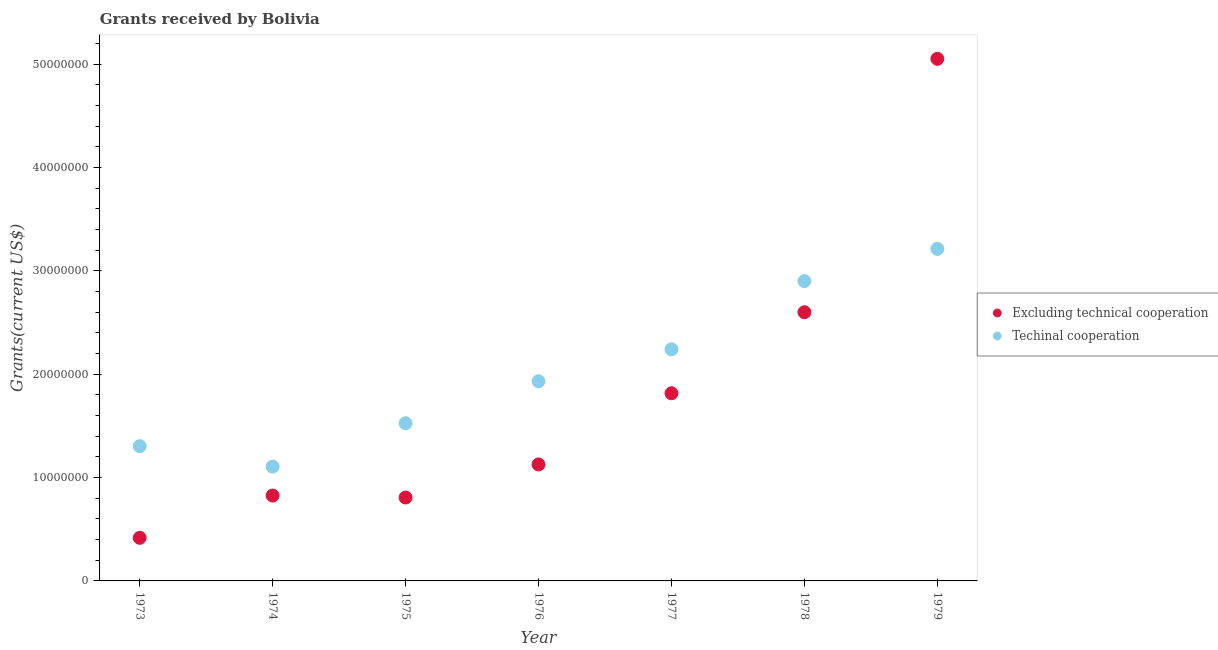How many different coloured dotlines are there?
Offer a very short reply. 2. What is the amount of grants received(including technical cooperation) in 1977?
Your answer should be very brief. 2.24e+07. Across all years, what is the maximum amount of grants received(including technical cooperation)?
Provide a succinct answer. 3.21e+07. Across all years, what is the minimum amount of grants received(excluding technical cooperation)?
Your answer should be compact. 4.17e+06. In which year was the amount of grants received(including technical cooperation) maximum?
Provide a succinct answer. 1979. In which year was the amount of grants received(including technical cooperation) minimum?
Provide a succinct answer. 1974. What is the total amount of grants received(including technical cooperation) in the graph?
Your answer should be very brief. 1.42e+08. What is the difference between the amount of grants received(including technical cooperation) in 1973 and that in 1979?
Your answer should be very brief. -1.91e+07. What is the difference between the amount of grants received(including technical cooperation) in 1974 and the amount of grants received(excluding technical cooperation) in 1977?
Provide a short and direct response. -7.10e+06. What is the average amount of grants received(including technical cooperation) per year?
Provide a succinct answer. 2.03e+07. In the year 1973, what is the difference between the amount of grants received(excluding technical cooperation) and amount of grants received(including technical cooperation)?
Offer a terse response. -8.87e+06. What is the ratio of the amount of grants received(including technical cooperation) in 1973 to that in 1977?
Your answer should be compact. 0.58. Is the amount of grants received(excluding technical cooperation) in 1975 less than that in 1976?
Keep it short and to the point. Yes. Is the difference between the amount of grants received(including technical cooperation) in 1975 and 1979 greater than the difference between the amount of grants received(excluding technical cooperation) in 1975 and 1979?
Your answer should be very brief. Yes. What is the difference between the highest and the second highest amount of grants received(excluding technical cooperation)?
Provide a short and direct response. 2.45e+07. What is the difference between the highest and the lowest amount of grants received(excluding technical cooperation)?
Your response must be concise. 4.64e+07. In how many years, is the amount of grants received(excluding technical cooperation) greater than the average amount of grants received(excluding technical cooperation) taken over all years?
Ensure brevity in your answer.  3. Is the sum of the amount of grants received(excluding technical cooperation) in 1974 and 1977 greater than the maximum amount of grants received(including technical cooperation) across all years?
Your answer should be compact. No. How many dotlines are there?
Offer a very short reply. 2. How many years are there in the graph?
Offer a very short reply. 7. What is the difference between two consecutive major ticks on the Y-axis?
Make the answer very short. 1.00e+07. Are the values on the major ticks of Y-axis written in scientific E-notation?
Offer a terse response. No. Does the graph contain any zero values?
Make the answer very short. No. How many legend labels are there?
Your answer should be compact. 2. What is the title of the graph?
Offer a very short reply. Grants received by Bolivia. Does "Chemicals" appear as one of the legend labels in the graph?
Provide a short and direct response. No. What is the label or title of the Y-axis?
Your response must be concise. Grants(current US$). What is the Grants(current US$) of Excluding technical cooperation in 1973?
Offer a terse response. 4.17e+06. What is the Grants(current US$) in Techinal cooperation in 1973?
Make the answer very short. 1.30e+07. What is the Grants(current US$) of Excluding technical cooperation in 1974?
Your response must be concise. 8.26e+06. What is the Grants(current US$) of Techinal cooperation in 1974?
Provide a short and direct response. 1.11e+07. What is the Grants(current US$) of Excluding technical cooperation in 1975?
Provide a succinct answer. 8.07e+06. What is the Grants(current US$) in Techinal cooperation in 1975?
Make the answer very short. 1.53e+07. What is the Grants(current US$) in Excluding technical cooperation in 1976?
Your answer should be very brief. 1.13e+07. What is the Grants(current US$) of Techinal cooperation in 1976?
Offer a terse response. 1.93e+07. What is the Grants(current US$) in Excluding technical cooperation in 1977?
Provide a short and direct response. 1.82e+07. What is the Grants(current US$) in Techinal cooperation in 1977?
Make the answer very short. 2.24e+07. What is the Grants(current US$) in Excluding technical cooperation in 1978?
Your response must be concise. 2.60e+07. What is the Grants(current US$) in Techinal cooperation in 1978?
Your response must be concise. 2.90e+07. What is the Grants(current US$) in Excluding technical cooperation in 1979?
Ensure brevity in your answer.  5.05e+07. What is the Grants(current US$) of Techinal cooperation in 1979?
Make the answer very short. 3.21e+07. Across all years, what is the maximum Grants(current US$) of Excluding technical cooperation?
Keep it short and to the point. 5.05e+07. Across all years, what is the maximum Grants(current US$) of Techinal cooperation?
Give a very brief answer. 3.21e+07. Across all years, what is the minimum Grants(current US$) of Excluding technical cooperation?
Your response must be concise. 4.17e+06. Across all years, what is the minimum Grants(current US$) in Techinal cooperation?
Give a very brief answer. 1.11e+07. What is the total Grants(current US$) in Excluding technical cooperation in the graph?
Your answer should be compact. 1.26e+08. What is the total Grants(current US$) in Techinal cooperation in the graph?
Your response must be concise. 1.42e+08. What is the difference between the Grants(current US$) in Excluding technical cooperation in 1973 and that in 1974?
Give a very brief answer. -4.09e+06. What is the difference between the Grants(current US$) in Techinal cooperation in 1973 and that in 1974?
Provide a succinct answer. 1.98e+06. What is the difference between the Grants(current US$) of Excluding technical cooperation in 1973 and that in 1975?
Offer a very short reply. -3.90e+06. What is the difference between the Grants(current US$) of Techinal cooperation in 1973 and that in 1975?
Keep it short and to the point. -2.22e+06. What is the difference between the Grants(current US$) in Excluding technical cooperation in 1973 and that in 1976?
Make the answer very short. -7.10e+06. What is the difference between the Grants(current US$) in Techinal cooperation in 1973 and that in 1976?
Ensure brevity in your answer.  -6.28e+06. What is the difference between the Grants(current US$) in Excluding technical cooperation in 1973 and that in 1977?
Offer a very short reply. -1.40e+07. What is the difference between the Grants(current US$) in Techinal cooperation in 1973 and that in 1977?
Provide a short and direct response. -9.37e+06. What is the difference between the Grants(current US$) of Excluding technical cooperation in 1973 and that in 1978?
Ensure brevity in your answer.  -2.18e+07. What is the difference between the Grants(current US$) in Techinal cooperation in 1973 and that in 1978?
Provide a short and direct response. -1.60e+07. What is the difference between the Grants(current US$) of Excluding technical cooperation in 1973 and that in 1979?
Your answer should be compact. -4.64e+07. What is the difference between the Grants(current US$) in Techinal cooperation in 1973 and that in 1979?
Provide a short and direct response. -1.91e+07. What is the difference between the Grants(current US$) in Excluding technical cooperation in 1974 and that in 1975?
Keep it short and to the point. 1.90e+05. What is the difference between the Grants(current US$) in Techinal cooperation in 1974 and that in 1975?
Ensure brevity in your answer.  -4.20e+06. What is the difference between the Grants(current US$) of Excluding technical cooperation in 1974 and that in 1976?
Your answer should be very brief. -3.01e+06. What is the difference between the Grants(current US$) of Techinal cooperation in 1974 and that in 1976?
Offer a terse response. -8.26e+06. What is the difference between the Grants(current US$) in Excluding technical cooperation in 1974 and that in 1977?
Provide a succinct answer. -9.90e+06. What is the difference between the Grants(current US$) in Techinal cooperation in 1974 and that in 1977?
Keep it short and to the point. -1.14e+07. What is the difference between the Grants(current US$) in Excluding technical cooperation in 1974 and that in 1978?
Keep it short and to the point. -1.77e+07. What is the difference between the Grants(current US$) in Techinal cooperation in 1974 and that in 1978?
Your answer should be compact. -1.80e+07. What is the difference between the Grants(current US$) of Excluding technical cooperation in 1974 and that in 1979?
Your response must be concise. -4.23e+07. What is the difference between the Grants(current US$) of Techinal cooperation in 1974 and that in 1979?
Ensure brevity in your answer.  -2.11e+07. What is the difference between the Grants(current US$) in Excluding technical cooperation in 1975 and that in 1976?
Your answer should be very brief. -3.20e+06. What is the difference between the Grants(current US$) of Techinal cooperation in 1975 and that in 1976?
Ensure brevity in your answer.  -4.06e+06. What is the difference between the Grants(current US$) in Excluding technical cooperation in 1975 and that in 1977?
Make the answer very short. -1.01e+07. What is the difference between the Grants(current US$) of Techinal cooperation in 1975 and that in 1977?
Make the answer very short. -7.15e+06. What is the difference between the Grants(current US$) in Excluding technical cooperation in 1975 and that in 1978?
Keep it short and to the point. -1.79e+07. What is the difference between the Grants(current US$) in Techinal cooperation in 1975 and that in 1978?
Your answer should be very brief. -1.38e+07. What is the difference between the Grants(current US$) in Excluding technical cooperation in 1975 and that in 1979?
Provide a succinct answer. -4.24e+07. What is the difference between the Grants(current US$) of Techinal cooperation in 1975 and that in 1979?
Ensure brevity in your answer.  -1.69e+07. What is the difference between the Grants(current US$) of Excluding technical cooperation in 1976 and that in 1977?
Offer a very short reply. -6.89e+06. What is the difference between the Grants(current US$) in Techinal cooperation in 1976 and that in 1977?
Provide a short and direct response. -3.09e+06. What is the difference between the Grants(current US$) of Excluding technical cooperation in 1976 and that in 1978?
Your answer should be very brief. -1.47e+07. What is the difference between the Grants(current US$) in Techinal cooperation in 1976 and that in 1978?
Keep it short and to the point. -9.69e+06. What is the difference between the Grants(current US$) of Excluding technical cooperation in 1976 and that in 1979?
Your answer should be very brief. -3.92e+07. What is the difference between the Grants(current US$) in Techinal cooperation in 1976 and that in 1979?
Offer a terse response. -1.28e+07. What is the difference between the Grants(current US$) of Excluding technical cooperation in 1977 and that in 1978?
Provide a short and direct response. -7.84e+06. What is the difference between the Grants(current US$) in Techinal cooperation in 1977 and that in 1978?
Make the answer very short. -6.60e+06. What is the difference between the Grants(current US$) of Excluding technical cooperation in 1977 and that in 1979?
Provide a succinct answer. -3.24e+07. What is the difference between the Grants(current US$) in Techinal cooperation in 1977 and that in 1979?
Ensure brevity in your answer.  -9.72e+06. What is the difference between the Grants(current US$) in Excluding technical cooperation in 1978 and that in 1979?
Offer a terse response. -2.45e+07. What is the difference between the Grants(current US$) in Techinal cooperation in 1978 and that in 1979?
Your answer should be very brief. -3.12e+06. What is the difference between the Grants(current US$) in Excluding technical cooperation in 1973 and the Grants(current US$) in Techinal cooperation in 1974?
Offer a very short reply. -6.89e+06. What is the difference between the Grants(current US$) of Excluding technical cooperation in 1973 and the Grants(current US$) of Techinal cooperation in 1975?
Ensure brevity in your answer.  -1.11e+07. What is the difference between the Grants(current US$) of Excluding technical cooperation in 1973 and the Grants(current US$) of Techinal cooperation in 1976?
Keep it short and to the point. -1.52e+07. What is the difference between the Grants(current US$) of Excluding technical cooperation in 1973 and the Grants(current US$) of Techinal cooperation in 1977?
Provide a short and direct response. -1.82e+07. What is the difference between the Grants(current US$) of Excluding technical cooperation in 1973 and the Grants(current US$) of Techinal cooperation in 1978?
Offer a terse response. -2.48e+07. What is the difference between the Grants(current US$) in Excluding technical cooperation in 1973 and the Grants(current US$) in Techinal cooperation in 1979?
Provide a succinct answer. -2.80e+07. What is the difference between the Grants(current US$) of Excluding technical cooperation in 1974 and the Grants(current US$) of Techinal cooperation in 1975?
Give a very brief answer. -7.00e+06. What is the difference between the Grants(current US$) in Excluding technical cooperation in 1974 and the Grants(current US$) in Techinal cooperation in 1976?
Make the answer very short. -1.11e+07. What is the difference between the Grants(current US$) of Excluding technical cooperation in 1974 and the Grants(current US$) of Techinal cooperation in 1977?
Offer a terse response. -1.42e+07. What is the difference between the Grants(current US$) in Excluding technical cooperation in 1974 and the Grants(current US$) in Techinal cooperation in 1978?
Ensure brevity in your answer.  -2.08e+07. What is the difference between the Grants(current US$) of Excluding technical cooperation in 1974 and the Grants(current US$) of Techinal cooperation in 1979?
Your response must be concise. -2.39e+07. What is the difference between the Grants(current US$) of Excluding technical cooperation in 1975 and the Grants(current US$) of Techinal cooperation in 1976?
Offer a terse response. -1.12e+07. What is the difference between the Grants(current US$) of Excluding technical cooperation in 1975 and the Grants(current US$) of Techinal cooperation in 1977?
Your answer should be compact. -1.43e+07. What is the difference between the Grants(current US$) of Excluding technical cooperation in 1975 and the Grants(current US$) of Techinal cooperation in 1978?
Your answer should be compact. -2.09e+07. What is the difference between the Grants(current US$) of Excluding technical cooperation in 1975 and the Grants(current US$) of Techinal cooperation in 1979?
Your response must be concise. -2.41e+07. What is the difference between the Grants(current US$) in Excluding technical cooperation in 1976 and the Grants(current US$) in Techinal cooperation in 1977?
Ensure brevity in your answer.  -1.11e+07. What is the difference between the Grants(current US$) of Excluding technical cooperation in 1976 and the Grants(current US$) of Techinal cooperation in 1978?
Keep it short and to the point. -1.77e+07. What is the difference between the Grants(current US$) of Excluding technical cooperation in 1976 and the Grants(current US$) of Techinal cooperation in 1979?
Offer a terse response. -2.09e+07. What is the difference between the Grants(current US$) of Excluding technical cooperation in 1977 and the Grants(current US$) of Techinal cooperation in 1978?
Keep it short and to the point. -1.08e+07. What is the difference between the Grants(current US$) of Excluding technical cooperation in 1977 and the Grants(current US$) of Techinal cooperation in 1979?
Your answer should be compact. -1.40e+07. What is the difference between the Grants(current US$) of Excluding technical cooperation in 1978 and the Grants(current US$) of Techinal cooperation in 1979?
Ensure brevity in your answer.  -6.13e+06. What is the average Grants(current US$) of Excluding technical cooperation per year?
Your answer should be compact. 1.81e+07. What is the average Grants(current US$) in Techinal cooperation per year?
Ensure brevity in your answer.  2.03e+07. In the year 1973, what is the difference between the Grants(current US$) of Excluding technical cooperation and Grants(current US$) of Techinal cooperation?
Your answer should be compact. -8.87e+06. In the year 1974, what is the difference between the Grants(current US$) in Excluding technical cooperation and Grants(current US$) in Techinal cooperation?
Offer a very short reply. -2.80e+06. In the year 1975, what is the difference between the Grants(current US$) of Excluding technical cooperation and Grants(current US$) of Techinal cooperation?
Ensure brevity in your answer.  -7.19e+06. In the year 1976, what is the difference between the Grants(current US$) of Excluding technical cooperation and Grants(current US$) of Techinal cooperation?
Keep it short and to the point. -8.05e+06. In the year 1977, what is the difference between the Grants(current US$) in Excluding technical cooperation and Grants(current US$) in Techinal cooperation?
Keep it short and to the point. -4.25e+06. In the year 1978, what is the difference between the Grants(current US$) in Excluding technical cooperation and Grants(current US$) in Techinal cooperation?
Offer a very short reply. -3.01e+06. In the year 1979, what is the difference between the Grants(current US$) in Excluding technical cooperation and Grants(current US$) in Techinal cooperation?
Your response must be concise. 1.84e+07. What is the ratio of the Grants(current US$) of Excluding technical cooperation in 1973 to that in 1974?
Provide a short and direct response. 0.5. What is the ratio of the Grants(current US$) in Techinal cooperation in 1973 to that in 1974?
Give a very brief answer. 1.18. What is the ratio of the Grants(current US$) of Excluding technical cooperation in 1973 to that in 1975?
Make the answer very short. 0.52. What is the ratio of the Grants(current US$) in Techinal cooperation in 1973 to that in 1975?
Your answer should be compact. 0.85. What is the ratio of the Grants(current US$) of Excluding technical cooperation in 1973 to that in 1976?
Your answer should be very brief. 0.37. What is the ratio of the Grants(current US$) in Techinal cooperation in 1973 to that in 1976?
Provide a succinct answer. 0.67. What is the ratio of the Grants(current US$) of Excluding technical cooperation in 1973 to that in 1977?
Provide a short and direct response. 0.23. What is the ratio of the Grants(current US$) in Techinal cooperation in 1973 to that in 1977?
Offer a terse response. 0.58. What is the ratio of the Grants(current US$) of Excluding technical cooperation in 1973 to that in 1978?
Keep it short and to the point. 0.16. What is the ratio of the Grants(current US$) of Techinal cooperation in 1973 to that in 1978?
Your answer should be compact. 0.45. What is the ratio of the Grants(current US$) of Excluding technical cooperation in 1973 to that in 1979?
Keep it short and to the point. 0.08. What is the ratio of the Grants(current US$) of Techinal cooperation in 1973 to that in 1979?
Keep it short and to the point. 0.41. What is the ratio of the Grants(current US$) of Excluding technical cooperation in 1974 to that in 1975?
Provide a succinct answer. 1.02. What is the ratio of the Grants(current US$) in Techinal cooperation in 1974 to that in 1975?
Ensure brevity in your answer.  0.72. What is the ratio of the Grants(current US$) of Excluding technical cooperation in 1974 to that in 1976?
Ensure brevity in your answer.  0.73. What is the ratio of the Grants(current US$) of Techinal cooperation in 1974 to that in 1976?
Ensure brevity in your answer.  0.57. What is the ratio of the Grants(current US$) in Excluding technical cooperation in 1974 to that in 1977?
Offer a terse response. 0.45. What is the ratio of the Grants(current US$) in Techinal cooperation in 1974 to that in 1977?
Offer a terse response. 0.49. What is the ratio of the Grants(current US$) in Excluding technical cooperation in 1974 to that in 1978?
Give a very brief answer. 0.32. What is the ratio of the Grants(current US$) in Techinal cooperation in 1974 to that in 1978?
Your answer should be compact. 0.38. What is the ratio of the Grants(current US$) of Excluding technical cooperation in 1974 to that in 1979?
Your answer should be compact. 0.16. What is the ratio of the Grants(current US$) of Techinal cooperation in 1974 to that in 1979?
Your answer should be compact. 0.34. What is the ratio of the Grants(current US$) of Excluding technical cooperation in 1975 to that in 1976?
Give a very brief answer. 0.72. What is the ratio of the Grants(current US$) in Techinal cooperation in 1975 to that in 1976?
Offer a very short reply. 0.79. What is the ratio of the Grants(current US$) of Excluding technical cooperation in 1975 to that in 1977?
Provide a succinct answer. 0.44. What is the ratio of the Grants(current US$) in Techinal cooperation in 1975 to that in 1977?
Make the answer very short. 0.68. What is the ratio of the Grants(current US$) in Excluding technical cooperation in 1975 to that in 1978?
Your response must be concise. 0.31. What is the ratio of the Grants(current US$) in Techinal cooperation in 1975 to that in 1978?
Your answer should be compact. 0.53. What is the ratio of the Grants(current US$) of Excluding technical cooperation in 1975 to that in 1979?
Ensure brevity in your answer.  0.16. What is the ratio of the Grants(current US$) of Techinal cooperation in 1975 to that in 1979?
Keep it short and to the point. 0.47. What is the ratio of the Grants(current US$) in Excluding technical cooperation in 1976 to that in 1977?
Your answer should be very brief. 0.62. What is the ratio of the Grants(current US$) of Techinal cooperation in 1976 to that in 1977?
Provide a short and direct response. 0.86. What is the ratio of the Grants(current US$) in Excluding technical cooperation in 1976 to that in 1978?
Provide a succinct answer. 0.43. What is the ratio of the Grants(current US$) of Techinal cooperation in 1976 to that in 1978?
Ensure brevity in your answer.  0.67. What is the ratio of the Grants(current US$) of Excluding technical cooperation in 1976 to that in 1979?
Offer a very short reply. 0.22. What is the ratio of the Grants(current US$) in Techinal cooperation in 1976 to that in 1979?
Your answer should be very brief. 0.6. What is the ratio of the Grants(current US$) of Excluding technical cooperation in 1977 to that in 1978?
Offer a terse response. 0.7. What is the ratio of the Grants(current US$) in Techinal cooperation in 1977 to that in 1978?
Offer a very short reply. 0.77. What is the ratio of the Grants(current US$) of Excluding technical cooperation in 1977 to that in 1979?
Ensure brevity in your answer.  0.36. What is the ratio of the Grants(current US$) in Techinal cooperation in 1977 to that in 1979?
Your answer should be very brief. 0.7. What is the ratio of the Grants(current US$) in Excluding technical cooperation in 1978 to that in 1979?
Provide a succinct answer. 0.51. What is the ratio of the Grants(current US$) in Techinal cooperation in 1978 to that in 1979?
Provide a short and direct response. 0.9. What is the difference between the highest and the second highest Grants(current US$) of Excluding technical cooperation?
Ensure brevity in your answer.  2.45e+07. What is the difference between the highest and the second highest Grants(current US$) of Techinal cooperation?
Ensure brevity in your answer.  3.12e+06. What is the difference between the highest and the lowest Grants(current US$) in Excluding technical cooperation?
Keep it short and to the point. 4.64e+07. What is the difference between the highest and the lowest Grants(current US$) of Techinal cooperation?
Provide a short and direct response. 2.11e+07. 